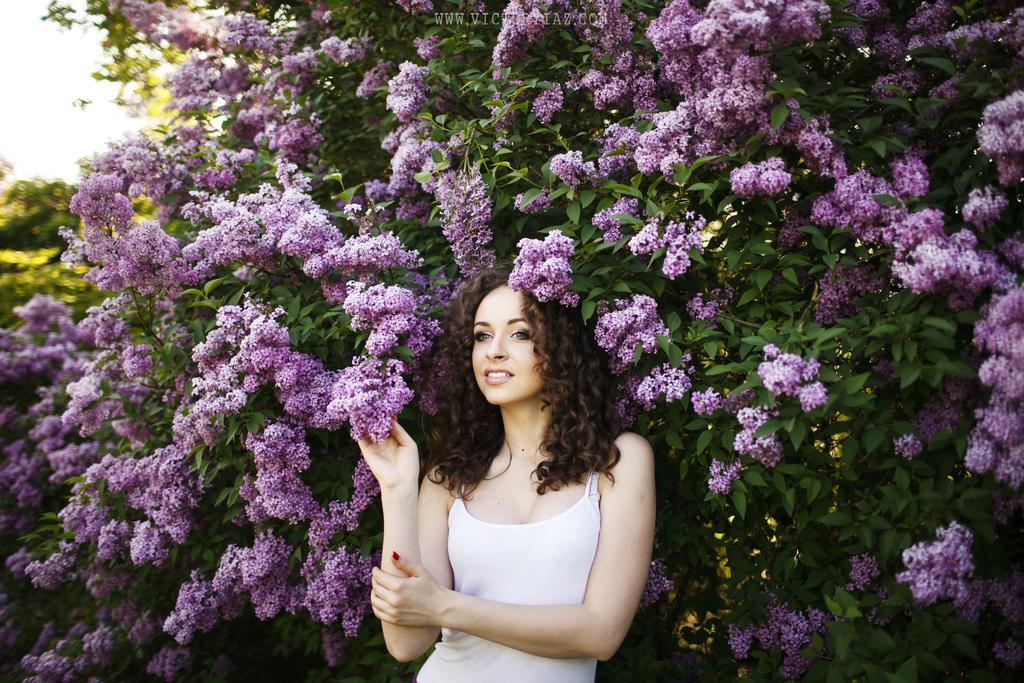Who is the main subject in the image? There is a lady in the center of the image. What can be seen in the background of the image? There are trees and flowers in the background of the image. What type of disease is the lady protesting against in the image? There is no protest or disease mentioned in the image; it simply shows a lady with trees and flowers in the background. 